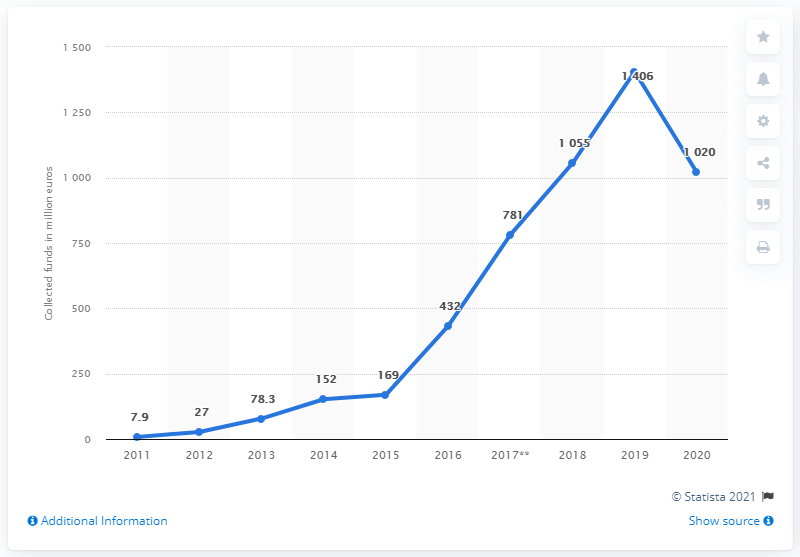Highlight a few significant elements in this photo. In 2013, the total amount of funds raised for crowdfunding projects was 78.3 million dollars. From 2015 to 2018, a total of 1406 funds were raised through crowdfunding. In 2014, the total amount of funding raised for crowdfunding projects was $152,000. 